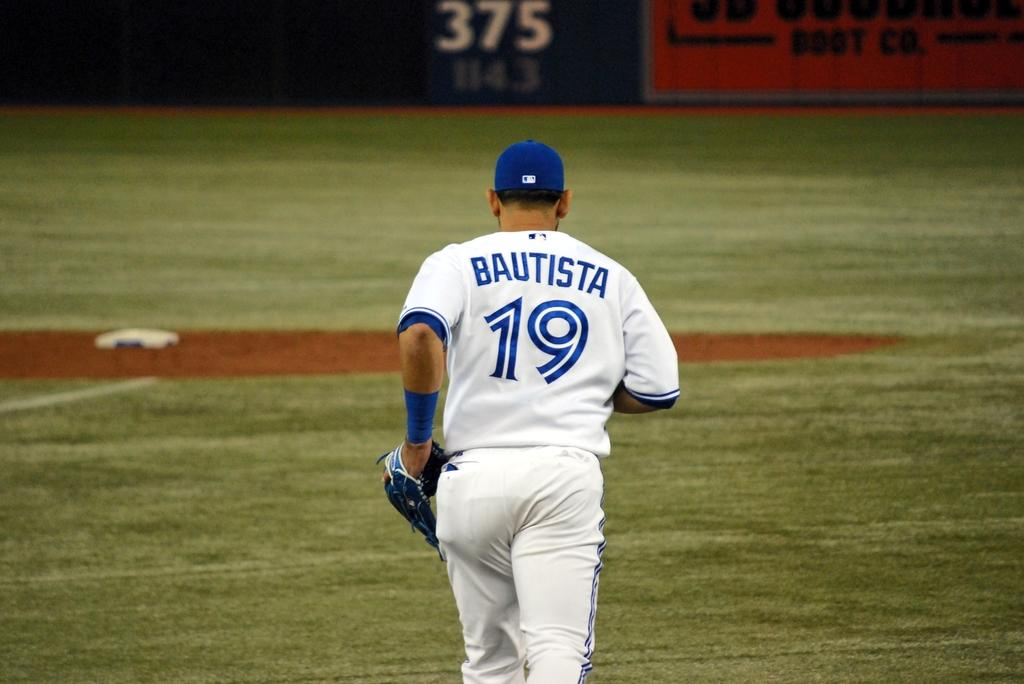<image>
Write a terse but informative summary of the picture. Baseball player number 19 on the field is Bautista. 